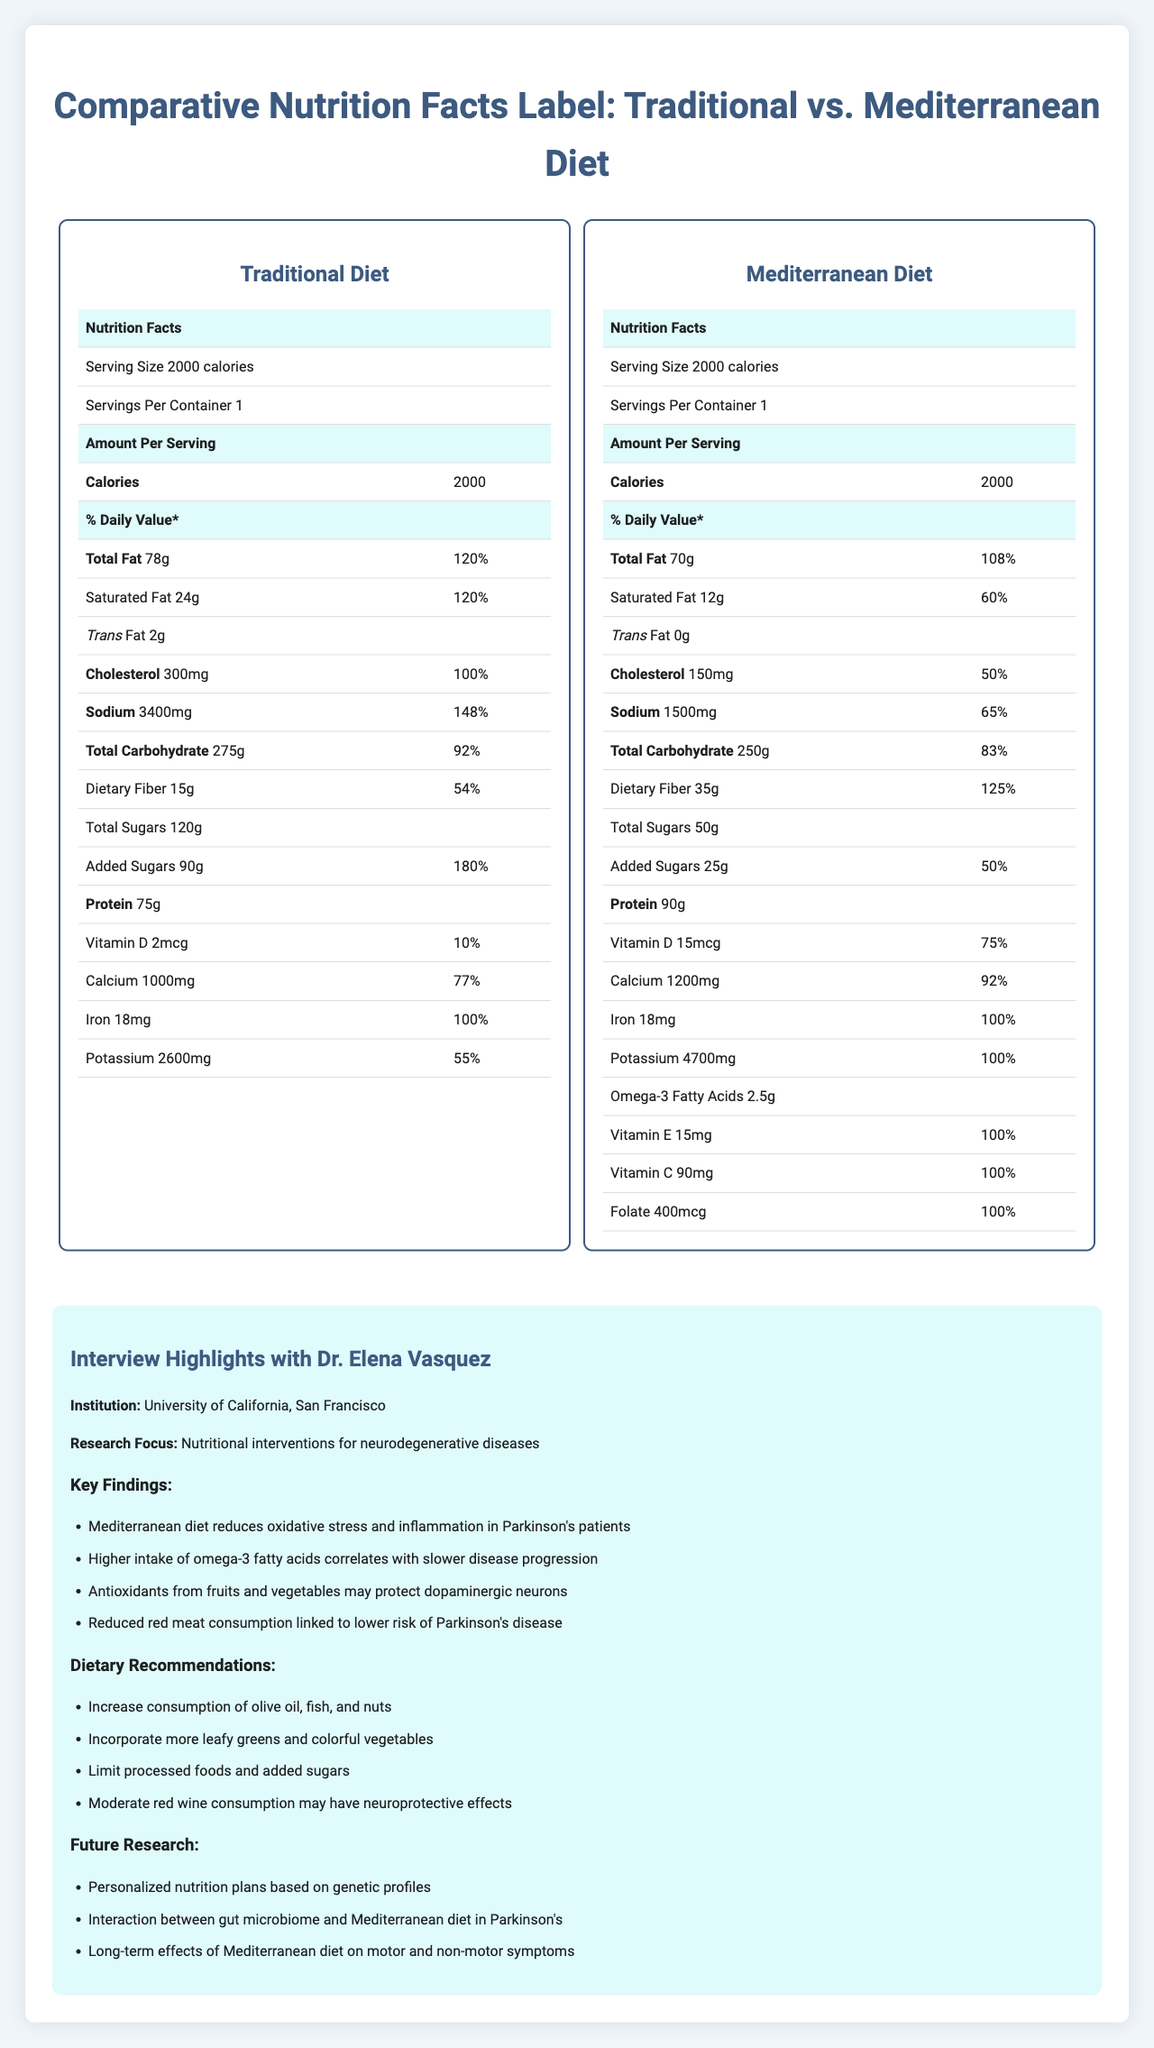what is the serving size for both diets? Both the traditional and Mediterranean diets have a serving size of 2000 calories, as stated in the nutrition labels for each diet.
Answer: 2000 calories how much total fat is in the Mediterranean diet? The nutrition label for the Mediterranean diet shows that it contains 70g of total fat.
Answer: 70g what is the daily value percentage of added sugars in the traditional diet? The traditional diet's nutrition label indicates that added sugars make up 180% of the daily value.
Answer: 180% which diet has more dietary fiber? The Mediterranean diet contains 35g of dietary fiber, while the traditional diet contains 15g.
Answer: Mediterranean diet how much protein is in the traditional diet compared to the Mediterranean diet? The traditional diet has 75g of protein, whereas the Mediterranean diet has 90g of protein.
Answer: Traditional: 75g, Mediterranean: 90g how much cholesterol does the Mediterranean diet contain? The Mediterranean diet's nutrition label shows it contains 150mg of cholesterol.
Answer: 150mg which diet has a higher sodium content? A. Traditional Diet B. Mediterranean Diet The traditional diet has 3400mg of sodium, whereas the Mediterranean diet has 1500mg.
Answer: A what level is the daily value percentage of saturated fat in the traditional diet? A. 60% B. 80% C. 100% D. 120% The traditional diet's nutrition label indicates that saturated fat is at 120% of the daily value.
Answer: D is there a difference in the amount of iron between the two diets? Both the traditional and Mediterranean diets contain 18mg of iron, which is 100% of the daily value.
Answer: No does the Mediterranean diet contain trans fat? The Mediterranean diet's nutrition label shows it contains 0g of trans fat.
Answer: No which diet includes omega-3 fatty acids? The Mediterranean diet includes 2.5g of omega-3 fatty acids, while the traditional diet does not list this nutrient.
Answer: Mediterranean diet what are the main benefits of the Mediterranean diet according to Dr. Elena Vasquez? Dr. Elena Vasquez's key findings indicate that the Mediterranean diet reduces oxidative stress and inflammation, has a higher intake of omega-3 fatty acids which correlates with slower disease progression, antioxidants from fruits and vegetables may protect dopaminergic neurons, and reduced red meat consumption is linked to a lower risk of Parkinson's disease.
Answer: Reduces oxidative stress and inflammation, correlates with slower disease progression, may protect dopaminergic neurons, linked to lower risk of Parkinson's disease what is the future research focus of Dr. Elena Vasquez? Dr. Elena Vasquez will focus on personalized nutrition plans based on genetic profiles, the interaction between the gut microbiome and the Mediterranean diet in Parkinson's, and the long-term effects of the Mediterranean diet on motor and non-motor symptoms.
Answer: Personalized nutrition plans, interaction between gut microbiome and Mediterranean diet, long-term effects on symptoms what are the daily value percentages of vitamin D in both diets? The traditional diet has 2mcg of vitamin D (10% DV), and the Mediterranean diet has 15mcg of vitamin D (75% DV).
Answer: Traditional: 10%, Mediterranean: 75% is the total carbohydrate content higher in the traditional diet compared to the Mediterranean diet? The traditional diet has 275g of total carbohydrates, whereas the Mediterranean diet has 250g.
Answer: Yes which nutrients are completely absent in the traditional diet but present in the Mediterranean diet? The traditional diet lacks omega-3 fatty acids, Vitamin E, Vitamin C, and Folate, which are present in the Mediterranean diet.
Answer: Omega-3 fatty acids, Vitamin E, Vitamin C, Folate what is the main idea of the document? The document provides a detailed comparison of nutrient profiles of traditional and Mediterranean diets, particularly emphasizing how the Mediterranean diet can benefit Parkinson's patients. It also features an interview with Dr. Elena Vasquez discussing her research findings, dietary recommendations, and future research directions.
Answer: The document compares the nutrition facts of traditional and Mediterranean diets and their implications for Parkinson's management, as well as highlighting Dr. Elena Vasquez's research on the benefits of the Mediterranean diet for neurodegenerative diseases. 